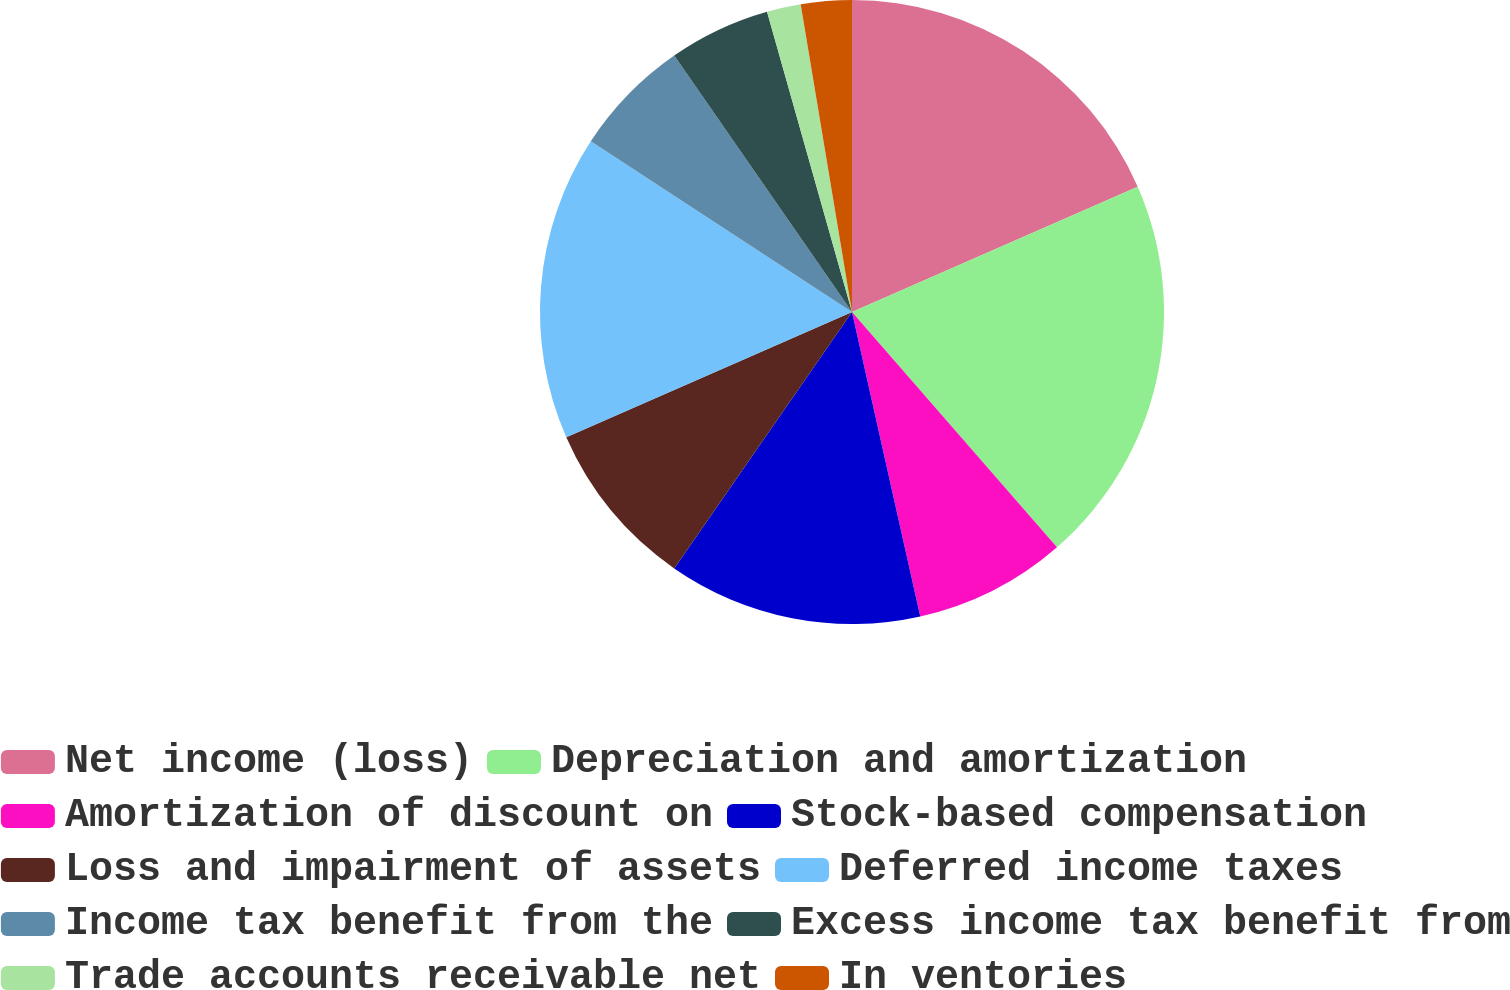Convert chart. <chart><loc_0><loc_0><loc_500><loc_500><pie_chart><fcel>Net income (loss)<fcel>Depreciation and amortization<fcel>Amortization of discount on<fcel>Stock-based compensation<fcel>Loss and impairment of assets<fcel>Deferred income taxes<fcel>Income tax benefit from the<fcel>Excess income tax benefit from<fcel>Trade accounts receivable net<fcel>In ventories<nl><fcel>18.42%<fcel>20.17%<fcel>7.9%<fcel>13.16%<fcel>8.77%<fcel>15.79%<fcel>6.14%<fcel>5.26%<fcel>1.76%<fcel>2.63%<nl></chart> 